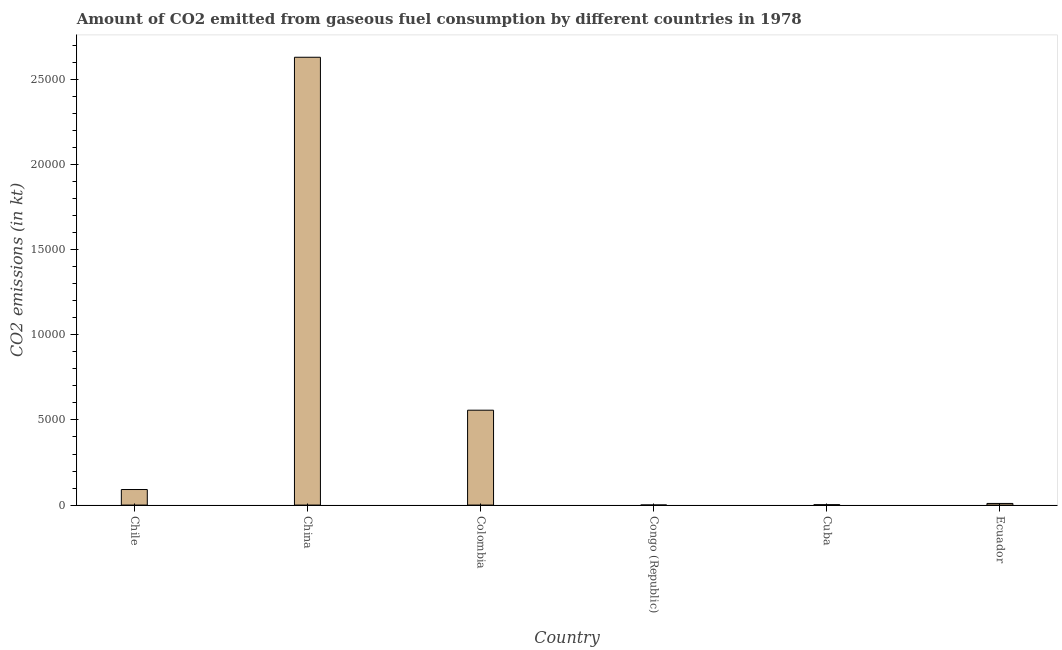Does the graph contain grids?
Make the answer very short. No. What is the title of the graph?
Offer a terse response. Amount of CO2 emitted from gaseous fuel consumption by different countries in 1978. What is the label or title of the Y-axis?
Give a very brief answer. CO2 emissions (in kt). What is the co2 emissions from gaseous fuel consumption in Colombia?
Provide a succinct answer. 5573.84. Across all countries, what is the maximum co2 emissions from gaseous fuel consumption?
Offer a terse response. 2.63e+04. Across all countries, what is the minimum co2 emissions from gaseous fuel consumption?
Offer a very short reply. 3.67. In which country was the co2 emissions from gaseous fuel consumption minimum?
Your response must be concise. Congo (Republic). What is the sum of the co2 emissions from gaseous fuel consumption?
Provide a succinct answer. 3.29e+04. What is the difference between the co2 emissions from gaseous fuel consumption in Chile and Cuba?
Make the answer very short. 891.08. What is the average co2 emissions from gaseous fuel consumption per country?
Make the answer very short. 5485.83. What is the median co2 emissions from gaseous fuel consumption?
Make the answer very short. 504.21. In how many countries, is the co2 emissions from gaseous fuel consumption greater than 14000 kt?
Your answer should be compact. 1. What is the ratio of the co2 emissions from gaseous fuel consumption in Chile to that in Congo (Republic)?
Your answer should be compact. 249. Is the co2 emissions from gaseous fuel consumption in Chile less than that in China?
Your response must be concise. Yes. Is the difference between the co2 emissions from gaseous fuel consumption in China and Congo (Republic) greater than the difference between any two countries?
Give a very brief answer. Yes. What is the difference between the highest and the second highest co2 emissions from gaseous fuel consumption?
Make the answer very short. 2.07e+04. What is the difference between the highest and the lowest co2 emissions from gaseous fuel consumption?
Offer a terse response. 2.63e+04. In how many countries, is the co2 emissions from gaseous fuel consumption greater than the average co2 emissions from gaseous fuel consumption taken over all countries?
Make the answer very short. 2. How many countries are there in the graph?
Provide a succinct answer. 6. What is the difference between two consecutive major ticks on the Y-axis?
Provide a succinct answer. 5000. What is the CO2 emissions (in kt) of Chile?
Provide a succinct answer. 913.08. What is the CO2 emissions (in kt) of China?
Ensure brevity in your answer.  2.63e+04. What is the CO2 emissions (in kt) in Colombia?
Provide a succinct answer. 5573.84. What is the CO2 emissions (in kt) of Congo (Republic)?
Offer a very short reply. 3.67. What is the CO2 emissions (in kt) in Cuba?
Keep it short and to the point. 22. What is the CO2 emissions (in kt) in Ecuador?
Your answer should be very brief. 95.34. What is the difference between the CO2 emissions (in kt) in Chile and China?
Ensure brevity in your answer.  -2.54e+04. What is the difference between the CO2 emissions (in kt) in Chile and Colombia?
Offer a very short reply. -4660.76. What is the difference between the CO2 emissions (in kt) in Chile and Congo (Republic)?
Your answer should be very brief. 909.42. What is the difference between the CO2 emissions (in kt) in Chile and Cuba?
Provide a short and direct response. 891.08. What is the difference between the CO2 emissions (in kt) in Chile and Ecuador?
Provide a short and direct response. 817.74. What is the difference between the CO2 emissions (in kt) in China and Colombia?
Offer a very short reply. 2.07e+04. What is the difference between the CO2 emissions (in kt) in China and Congo (Republic)?
Your response must be concise. 2.63e+04. What is the difference between the CO2 emissions (in kt) in China and Cuba?
Make the answer very short. 2.63e+04. What is the difference between the CO2 emissions (in kt) in China and Ecuador?
Your response must be concise. 2.62e+04. What is the difference between the CO2 emissions (in kt) in Colombia and Congo (Republic)?
Your answer should be compact. 5570.17. What is the difference between the CO2 emissions (in kt) in Colombia and Cuba?
Provide a short and direct response. 5551.84. What is the difference between the CO2 emissions (in kt) in Colombia and Ecuador?
Your answer should be very brief. 5478.5. What is the difference between the CO2 emissions (in kt) in Congo (Republic) and Cuba?
Your response must be concise. -18.34. What is the difference between the CO2 emissions (in kt) in Congo (Republic) and Ecuador?
Offer a very short reply. -91.67. What is the difference between the CO2 emissions (in kt) in Cuba and Ecuador?
Your answer should be compact. -73.34. What is the ratio of the CO2 emissions (in kt) in Chile to that in China?
Your response must be concise. 0.04. What is the ratio of the CO2 emissions (in kt) in Chile to that in Colombia?
Offer a terse response. 0.16. What is the ratio of the CO2 emissions (in kt) in Chile to that in Congo (Republic)?
Keep it short and to the point. 249. What is the ratio of the CO2 emissions (in kt) in Chile to that in Cuba?
Provide a short and direct response. 41.5. What is the ratio of the CO2 emissions (in kt) in Chile to that in Ecuador?
Your answer should be compact. 9.58. What is the ratio of the CO2 emissions (in kt) in China to that in Colombia?
Give a very brief answer. 4.72. What is the ratio of the CO2 emissions (in kt) in China to that in Congo (Republic)?
Your answer should be compact. 7174. What is the ratio of the CO2 emissions (in kt) in China to that in Cuba?
Offer a very short reply. 1195.67. What is the ratio of the CO2 emissions (in kt) in China to that in Ecuador?
Provide a succinct answer. 275.92. What is the ratio of the CO2 emissions (in kt) in Colombia to that in Congo (Republic)?
Make the answer very short. 1520. What is the ratio of the CO2 emissions (in kt) in Colombia to that in Cuba?
Ensure brevity in your answer.  253.33. What is the ratio of the CO2 emissions (in kt) in Colombia to that in Ecuador?
Offer a terse response. 58.46. What is the ratio of the CO2 emissions (in kt) in Congo (Republic) to that in Cuba?
Provide a succinct answer. 0.17. What is the ratio of the CO2 emissions (in kt) in Congo (Republic) to that in Ecuador?
Offer a very short reply. 0.04. What is the ratio of the CO2 emissions (in kt) in Cuba to that in Ecuador?
Ensure brevity in your answer.  0.23. 